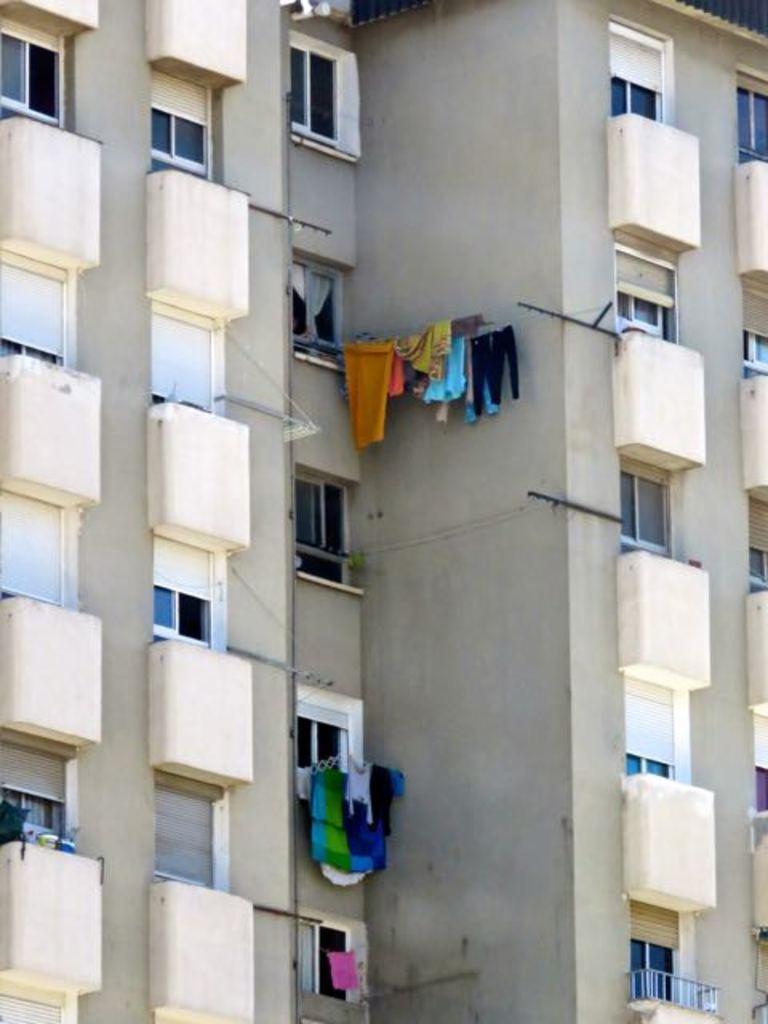How would you summarize this image in a sentence or two? In the picture I can see buildings, clothes hanged here, I can see glass windows and balcony. 